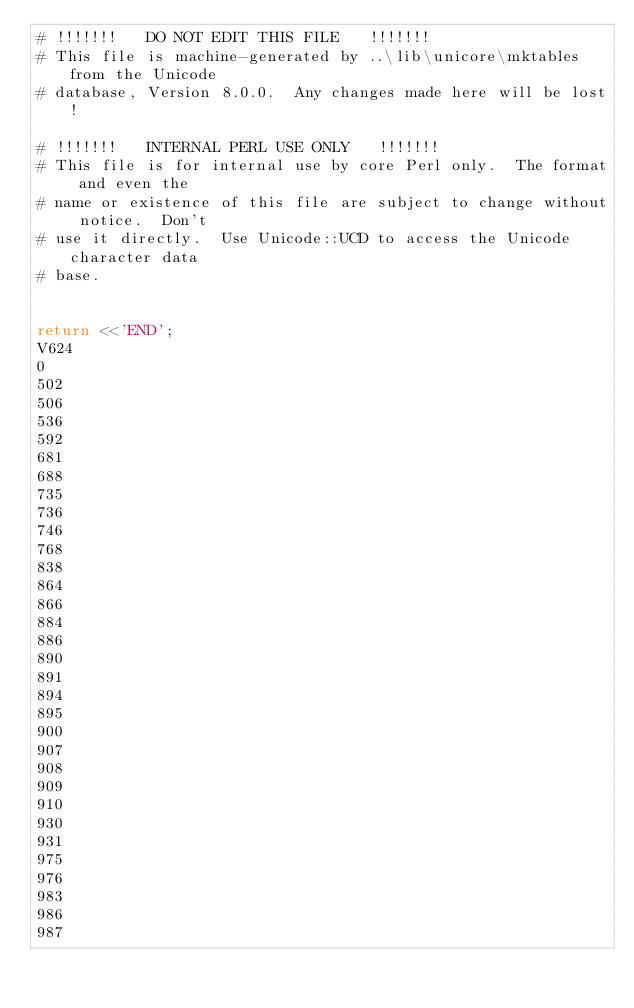<code> <loc_0><loc_0><loc_500><loc_500><_Perl_># !!!!!!!   DO NOT EDIT THIS FILE   !!!!!!!
# This file is machine-generated by ..\lib\unicore\mktables from the Unicode
# database, Version 8.0.0.  Any changes made here will be lost!

# !!!!!!!   INTERNAL PERL USE ONLY   !!!!!!!
# This file is for internal use by core Perl only.  The format and even the
# name or existence of this file are subject to change without notice.  Don't
# use it directly.  Use Unicode::UCD to access the Unicode character data
# base.


return <<'END';
V624
0
502
506
536
592
681
688
735
736
746
768
838
864
866
884
886
890
891
894
895
900
907
908
909
910
930
931
975
976
983
986
987</code> 